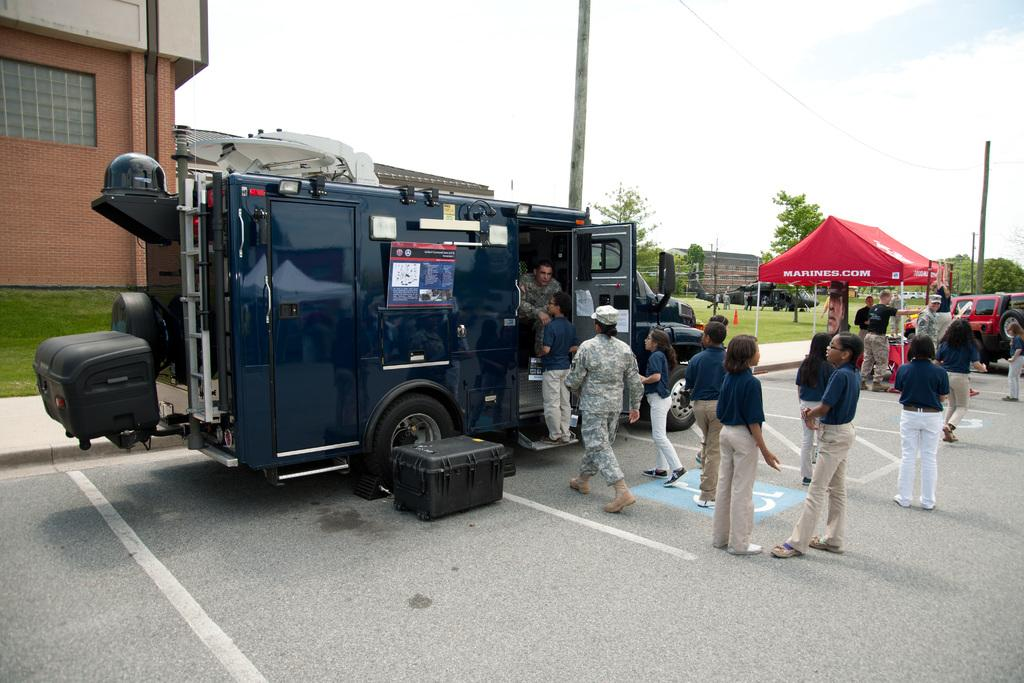What types of objects can be seen in the image? There are vehicles, a box, a tent, poles, and buildings in the image. What is the setting of the image? The image shows a group of people standing on the road, surrounded by grass, trees, and buildings. What can be seen in the background of the image? The sky is visible in the background of the image. What type of butter is being used to paint the canvas in the image? There is no butter or canvas present in the image. What kind of trouble are the people in the image experiencing? The image does not depict any trouble or difficulties being experienced by the people. 